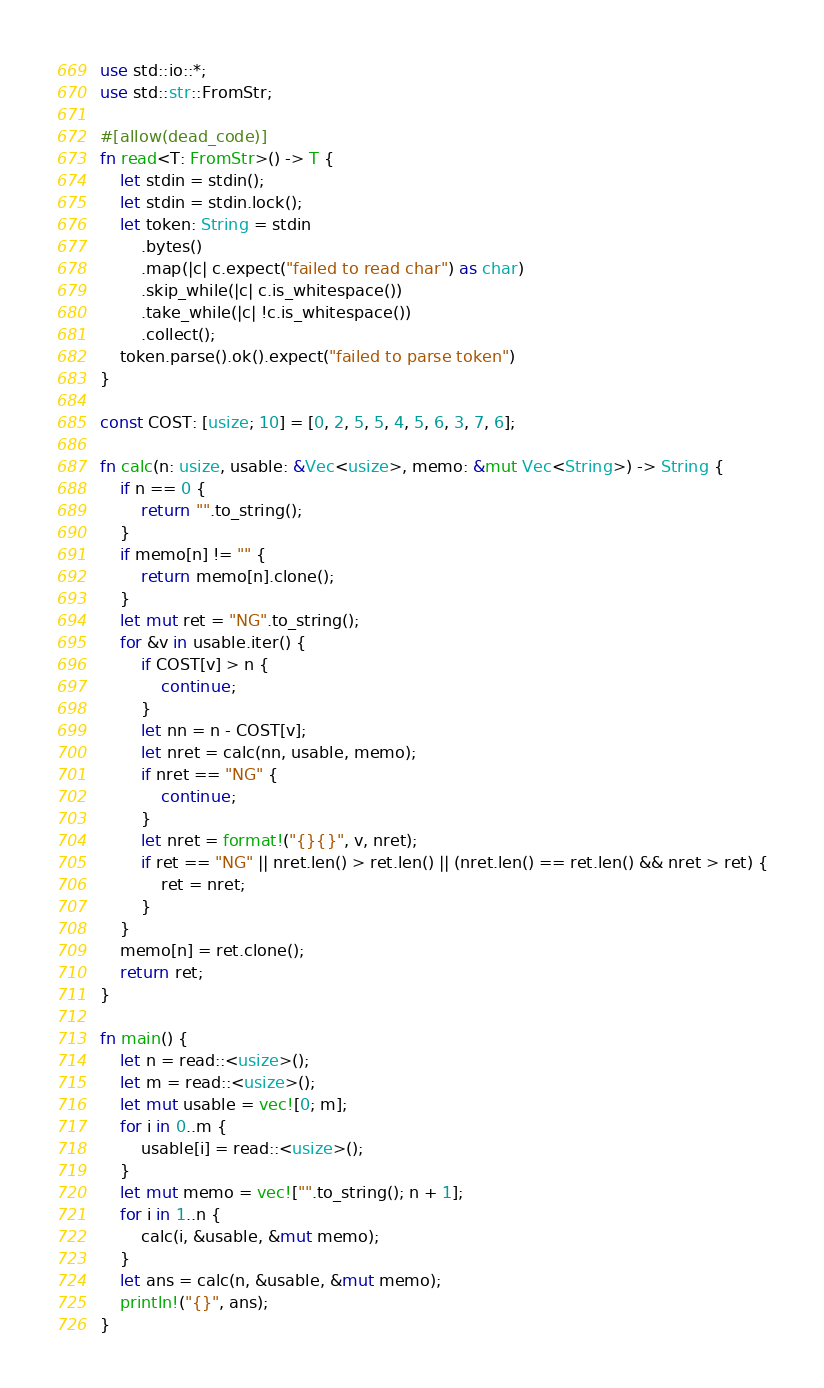Convert code to text. <code><loc_0><loc_0><loc_500><loc_500><_Rust_>use std::io::*;
use std::str::FromStr;

#[allow(dead_code)]
fn read<T: FromStr>() -> T {
    let stdin = stdin();
    let stdin = stdin.lock();
    let token: String = stdin
        .bytes()
        .map(|c| c.expect("failed to read char") as char)
        .skip_while(|c| c.is_whitespace())
        .take_while(|c| !c.is_whitespace())
        .collect();
    token.parse().ok().expect("failed to parse token")
}

const COST: [usize; 10] = [0, 2, 5, 5, 4, 5, 6, 3, 7, 6];

fn calc(n: usize, usable: &Vec<usize>, memo: &mut Vec<String>) -> String {
    if n == 0 {
        return "".to_string();
    }
    if memo[n] != "" {
        return memo[n].clone();
    }
    let mut ret = "NG".to_string();
    for &v in usable.iter() {
        if COST[v] > n {
            continue;
        }
        let nn = n - COST[v];
        let nret = calc(nn, usable, memo);
        if nret == "NG" {
            continue;
        }
        let nret = format!("{}{}", v, nret);
        if ret == "NG" || nret.len() > ret.len() || (nret.len() == ret.len() && nret > ret) {
            ret = nret;
        }
    }
    memo[n] = ret.clone();
    return ret;
}

fn main() {
    let n = read::<usize>();
    let m = read::<usize>();
    let mut usable = vec![0; m];
    for i in 0..m {
        usable[i] = read::<usize>();
    }
    let mut memo = vec!["".to_string(); n + 1];
    for i in 1..n {
        calc(i, &usable, &mut memo);
    }
    let ans = calc(n, &usable, &mut memo);
    println!("{}", ans);
}
</code> 